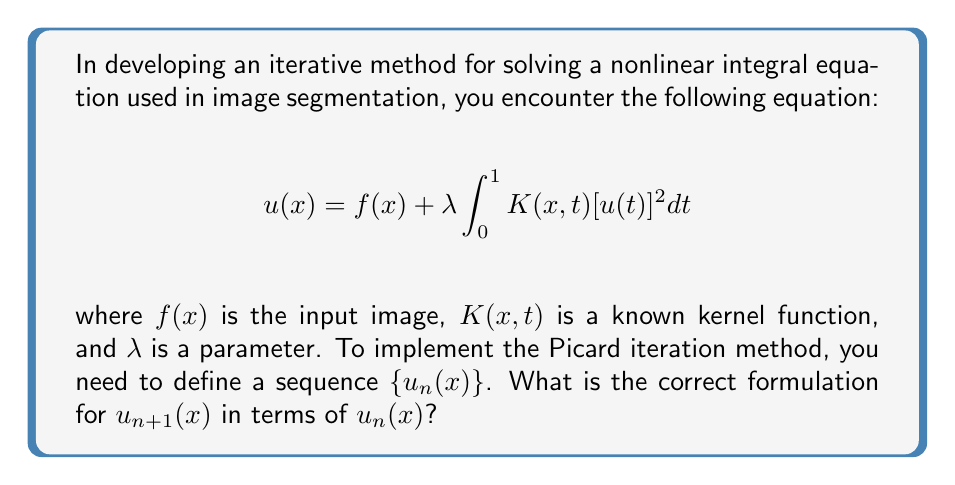Give your solution to this math problem. To solve this nonlinear integral equation using the Picard iteration method, we follow these steps:

1) The Picard iteration method involves creating a sequence of approximations, where each new approximation is obtained by substituting the previous approximation into the right-hand side of the equation.

2) In our case, we start with an initial guess $u_0(x)$, which could be $f(x)$ or another suitable function.

3) To obtain $u_{n+1}(x)$, we replace $u(x)$ on the left-hand side with $u_{n+1}(x)$, and replace $u(t)$ on the right-hand side with $u_n(t)$:

   $$u_{n+1}(x) = f(x) + \lambda \int_0^1 K(x,t)[u_n(t)]^2 dt$$

4) This formulation creates a recursive sequence where each iteration uses the result of the previous iteration.

5) The iteration continues until a convergence criterion is met, such as $\|u_{n+1} - u_n\| < \epsilon$ for some small $\epsilon > 0$.

6) In the context of image segmentation, this method allows for the progressive refinement of the segmentation result, with each iteration potentially improving the accuracy of the segmentation.

This formulation is particularly suitable for implementation in OCR software, as it provides a systematic way to iteratively improve the segmentation of complex images.
Answer: $$u_{n+1}(x) = f(x) + \lambda \int_0^1 K(x,t)[u_n(t)]^2 dt$$ 